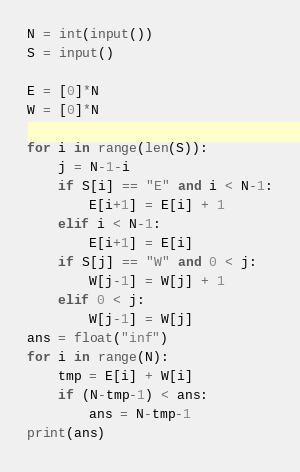<code> <loc_0><loc_0><loc_500><loc_500><_Python_>N = int(input())
S = input()

E = [0]*N
W = [0]*N

for i in range(len(S)):
    j = N-1-i
    if S[i] == "E" and i < N-1:
        E[i+1] = E[i] + 1
    elif i < N-1:
        E[i+1] = E[i]
    if S[j] == "W" and 0 < j:
        W[j-1] = W[j] + 1
    elif 0 < j:
        W[j-1] = W[j]
ans = float("inf")
for i in range(N):
    tmp = E[i] + W[i]
    if (N-tmp-1) < ans:
        ans = N-tmp-1
print(ans)</code> 